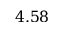<formula> <loc_0><loc_0><loc_500><loc_500>4 . 5 8</formula> 